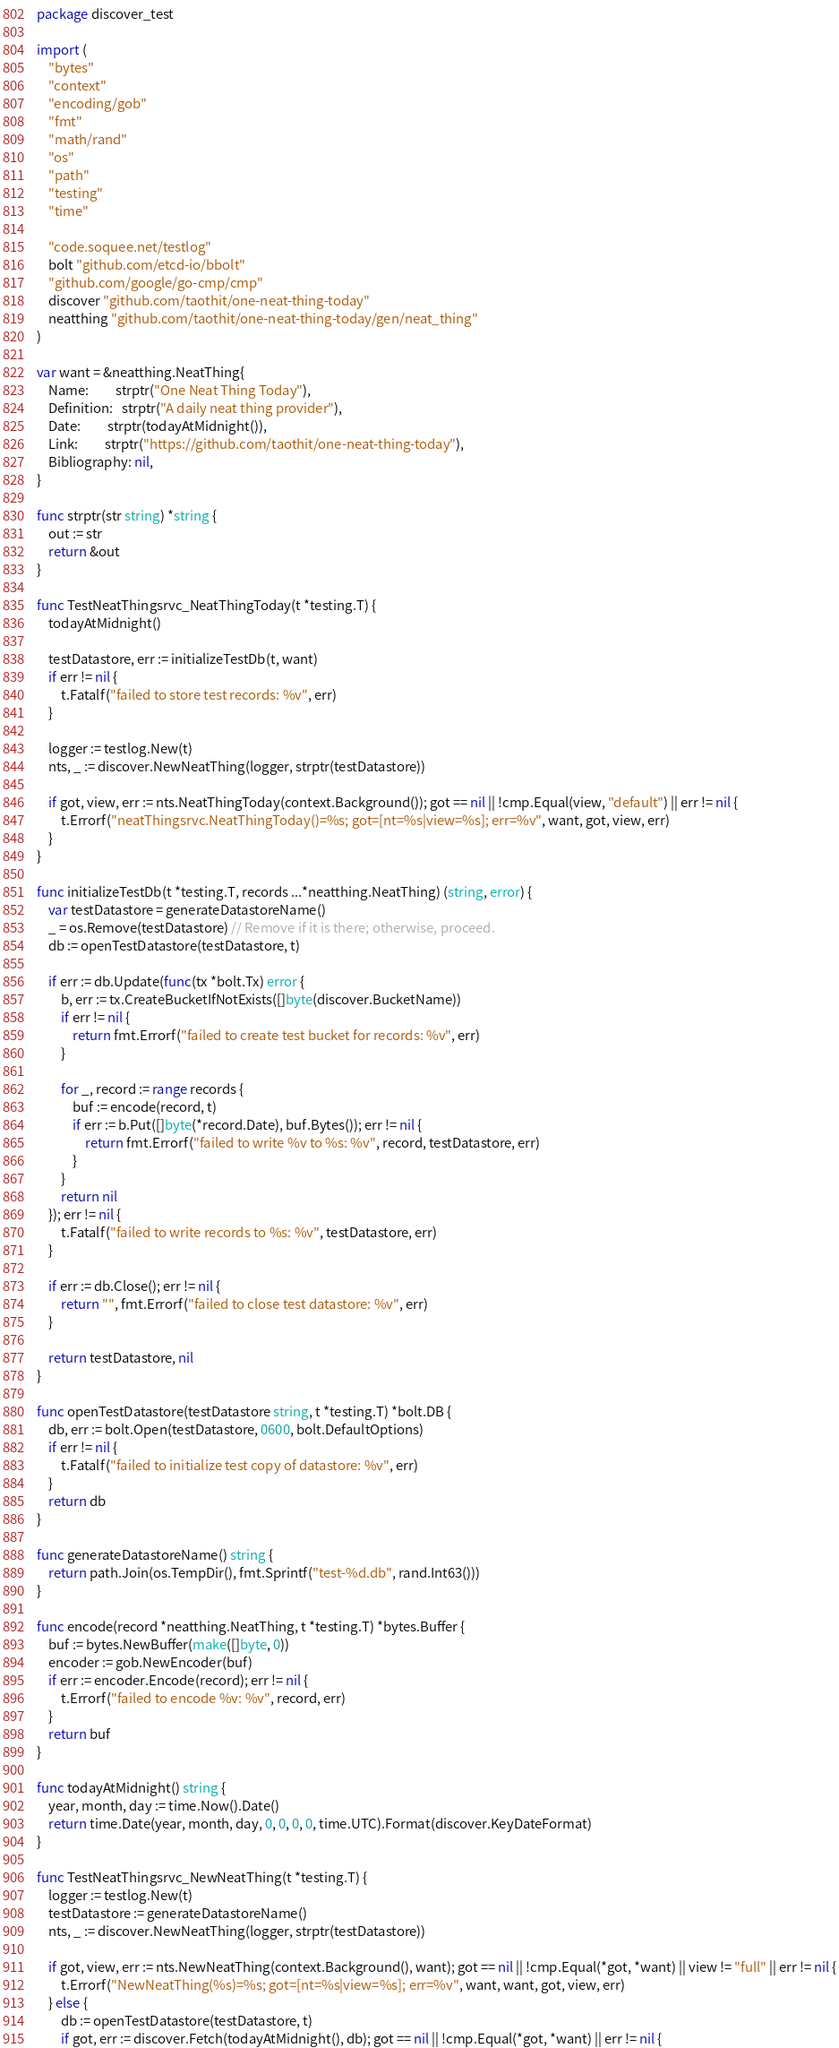Convert code to text. <code><loc_0><loc_0><loc_500><loc_500><_Go_>package discover_test

import (
	"bytes"
	"context"
	"encoding/gob"
	"fmt"
	"math/rand"
	"os"
	"path"
	"testing"
	"time"

	"code.soquee.net/testlog"
	bolt "github.com/etcd-io/bbolt"
	"github.com/google/go-cmp/cmp"
	discover "github.com/taothit/one-neat-thing-today"
	neatthing "github.com/taothit/one-neat-thing-today/gen/neat_thing"
)

var want = &neatthing.NeatThing{
	Name:         strptr("One Neat Thing Today"),
	Definition:   strptr("A daily neat thing provider"),
	Date:         strptr(todayAtMidnight()),
	Link:         strptr("https://github.com/taothit/one-neat-thing-today"),
	Bibliography: nil,
}

func strptr(str string) *string {
	out := str
	return &out
}

func TestNeatThingsrvc_NeatThingToday(t *testing.T) {
	todayAtMidnight()

	testDatastore, err := initializeTestDb(t, want)
	if err != nil {
		t.Fatalf("failed to store test records: %v", err)
	}

	logger := testlog.New(t)
	nts, _ := discover.NewNeatThing(logger, strptr(testDatastore))

	if got, view, err := nts.NeatThingToday(context.Background()); got == nil || !cmp.Equal(view, "default") || err != nil {
		t.Errorf("neatThingsrvc.NeatThingToday()=%s; got=[nt=%s|view=%s]; err=%v", want, got, view, err)
	}
}

func initializeTestDb(t *testing.T, records ...*neatthing.NeatThing) (string, error) {
	var testDatastore = generateDatastoreName()
	_ = os.Remove(testDatastore) // Remove if it is there; otherwise, proceed.
	db := openTestDatastore(testDatastore, t)

	if err := db.Update(func(tx *bolt.Tx) error {
		b, err := tx.CreateBucketIfNotExists([]byte(discover.BucketName))
		if err != nil {
			return fmt.Errorf("failed to create test bucket for records: %v", err)
		}

		for _, record := range records {
			buf := encode(record, t)
			if err := b.Put([]byte(*record.Date), buf.Bytes()); err != nil {
				return fmt.Errorf("failed to write %v to %s: %v", record, testDatastore, err)
			}
		}
		return nil
	}); err != nil {
		t.Fatalf("failed to write records to %s: %v", testDatastore, err)
	}

	if err := db.Close(); err != nil {
		return "", fmt.Errorf("failed to close test datastore: %v", err)
	}

	return testDatastore, nil
}

func openTestDatastore(testDatastore string, t *testing.T) *bolt.DB {
	db, err := bolt.Open(testDatastore, 0600, bolt.DefaultOptions)
	if err != nil {
		t.Fatalf("failed to initialize test copy of datastore: %v", err)
	}
	return db
}

func generateDatastoreName() string {
	return path.Join(os.TempDir(), fmt.Sprintf("test-%d.db", rand.Int63()))
}

func encode(record *neatthing.NeatThing, t *testing.T) *bytes.Buffer {
	buf := bytes.NewBuffer(make([]byte, 0))
	encoder := gob.NewEncoder(buf)
	if err := encoder.Encode(record); err != nil {
		t.Errorf("failed to encode %v: %v", record, err)
	}
	return buf
}

func todayAtMidnight() string {
	year, month, day := time.Now().Date()
	return time.Date(year, month, day, 0, 0, 0, 0, time.UTC).Format(discover.KeyDateFormat)
}

func TestNeatThingsrvc_NewNeatThing(t *testing.T) {
	logger := testlog.New(t)
	testDatastore := generateDatastoreName()
	nts, _ := discover.NewNeatThing(logger, strptr(testDatastore))

	if got, view, err := nts.NewNeatThing(context.Background(), want); got == nil || !cmp.Equal(*got, *want) || view != "full" || err != nil {
		t.Errorf("NewNeatThing(%s)=%s; got=[nt=%s|view=%s]; err=%v", want, want, got, view, err)
	} else {
		db := openTestDatastore(testDatastore, t)
		if got, err := discover.Fetch(todayAtMidnight(), db); got == nil || !cmp.Equal(*got, *want) || err != nil {</code> 